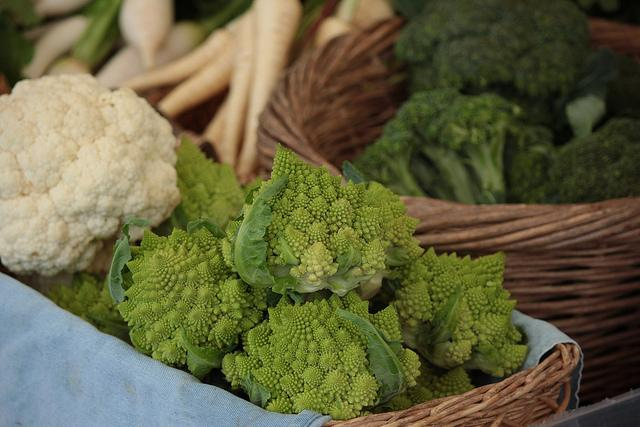What is the more realistic setting for these baskets of food items? farmer's market 